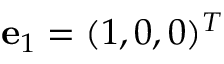<formula> <loc_0><loc_0><loc_500><loc_500>{ e } _ { 1 } = ( 1 , 0 , 0 ) ^ { T }</formula> 